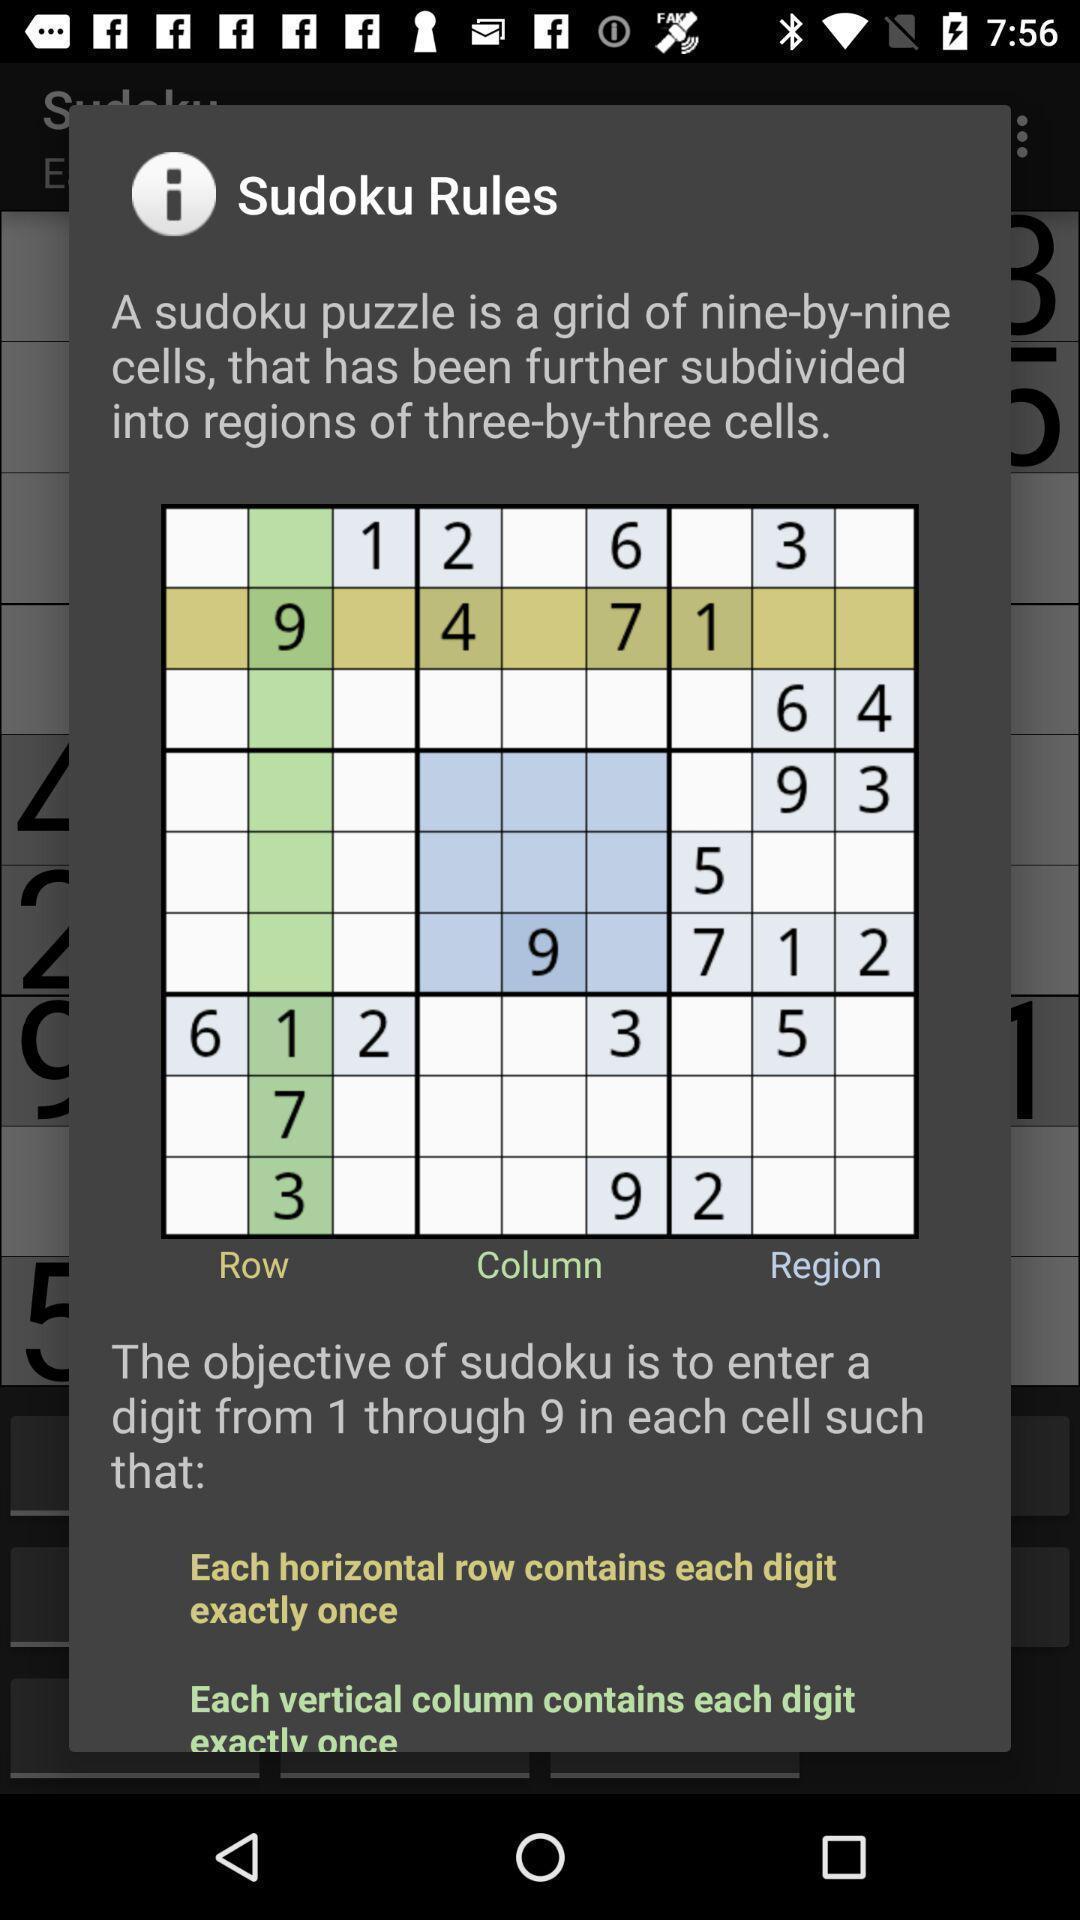What can you discern from this picture? Pop up showing sudoku puzzle. 